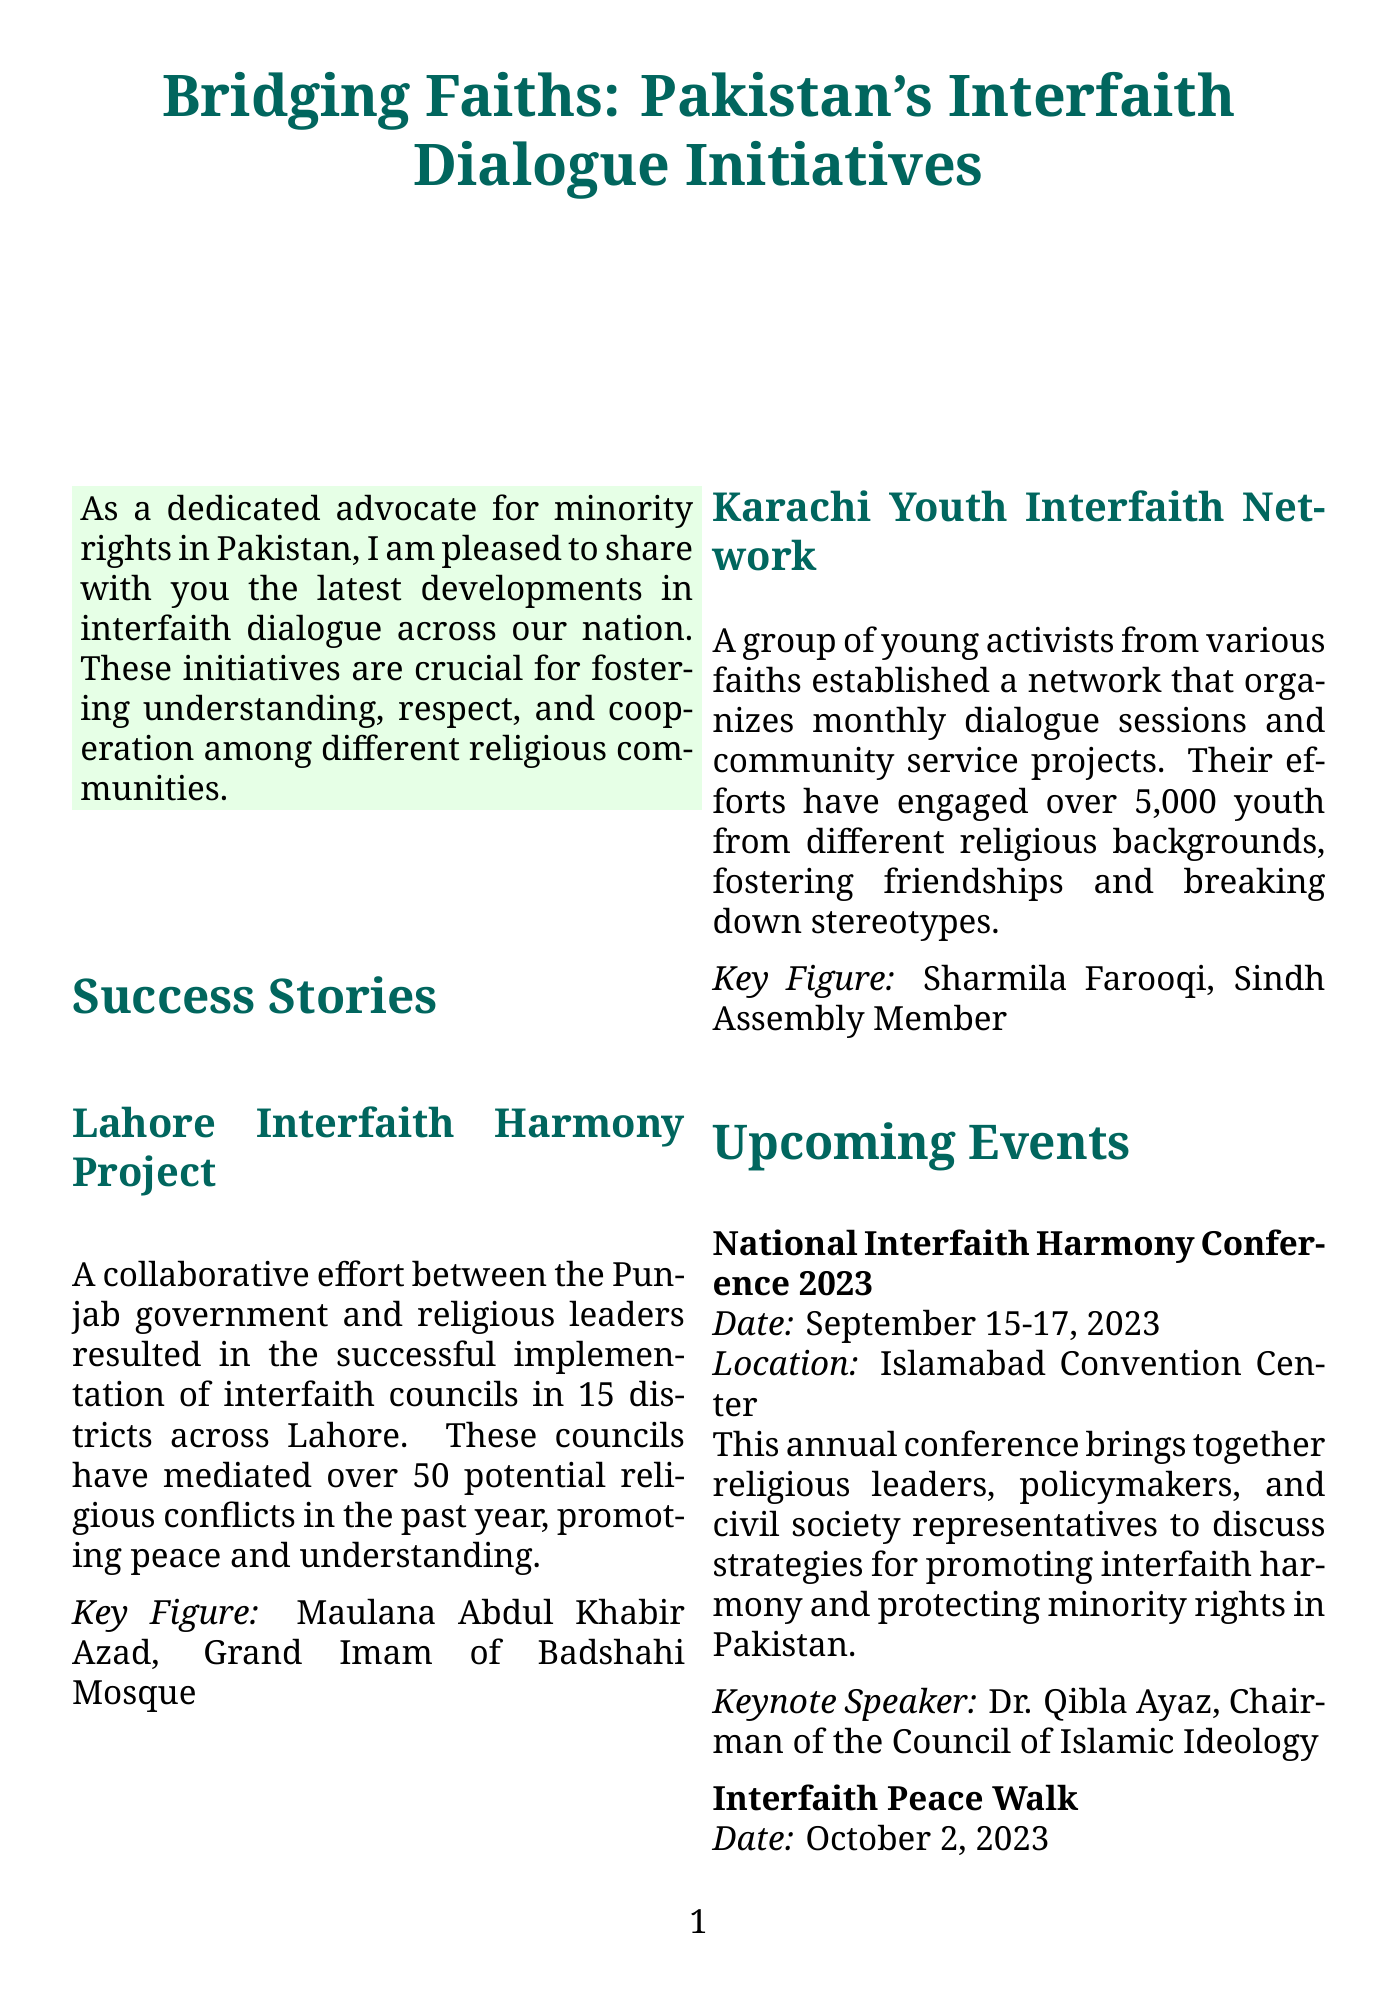What is the title of the newsletter? The title of the newsletter is located at the top of the document.
Answer: Bridging Faiths: Pakistan's Interfaith Dialogue Initiatives Who is the key figure in the Lahore Interfaith Harmony Project? The key figure mentioned in the success story of this project is stated clearly within its description.
Answer: Maulana Abdul Khabir Azad When is the National Interfaith Harmony Conference 2023 scheduled to take place? The date for this upcoming event is specified in the document.
Answer: September 15-17, 2023 How many youth have engaged with the Karachi Youth Interfaith Network? The document provides a specific figure regarding youth engagement in this initiative.
Answer: 5,000 What is the main goal of the Pakistan Interfaith League (PIL)? The document states the purpose of this ongoing initiative, thereby giving insights into its objectives.
Answer: Promote dialogue and cooperation Where will the Interfaith Peace Walk take place? The location for this symbolic event is explicitly mentioned in the newsletter.
Answer: Quetta Who is the project lead for the Curriculum Reform Project? The document identifies the person leading this significant educational initiative.
Answer: Dr. Pervez Hoodbhoy 